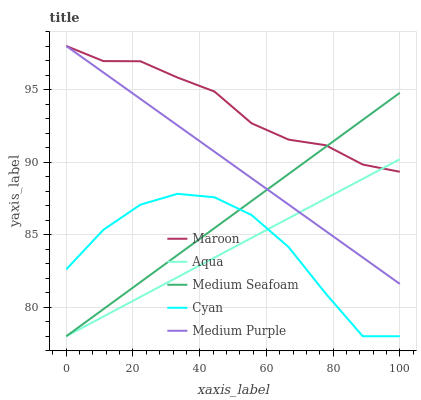Does Aqua have the minimum area under the curve?
Answer yes or no. Yes. Does Maroon have the maximum area under the curve?
Answer yes or no. Yes. Does Cyan have the minimum area under the curve?
Answer yes or no. No. Does Cyan have the maximum area under the curve?
Answer yes or no. No. Is Medium Purple the smoothest?
Answer yes or no. Yes. Is Cyan the roughest?
Answer yes or no. Yes. Is Aqua the smoothest?
Answer yes or no. No. Is Aqua the roughest?
Answer yes or no. No. Does Cyan have the lowest value?
Answer yes or no. Yes. Does Maroon have the lowest value?
Answer yes or no. No. Does Maroon have the highest value?
Answer yes or no. Yes. Does Aqua have the highest value?
Answer yes or no. No. Is Cyan less than Medium Purple?
Answer yes or no. Yes. Is Medium Purple greater than Cyan?
Answer yes or no. Yes. Does Medium Seafoam intersect Medium Purple?
Answer yes or no. Yes. Is Medium Seafoam less than Medium Purple?
Answer yes or no. No. Is Medium Seafoam greater than Medium Purple?
Answer yes or no. No. Does Cyan intersect Medium Purple?
Answer yes or no. No. 